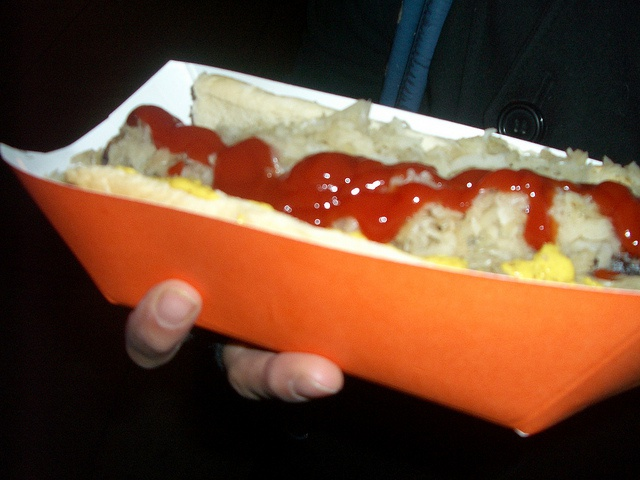Describe the objects in this image and their specific colors. I can see hot dog in black, brown, beige, and tan tones and people in black, brown, and salmon tones in this image. 